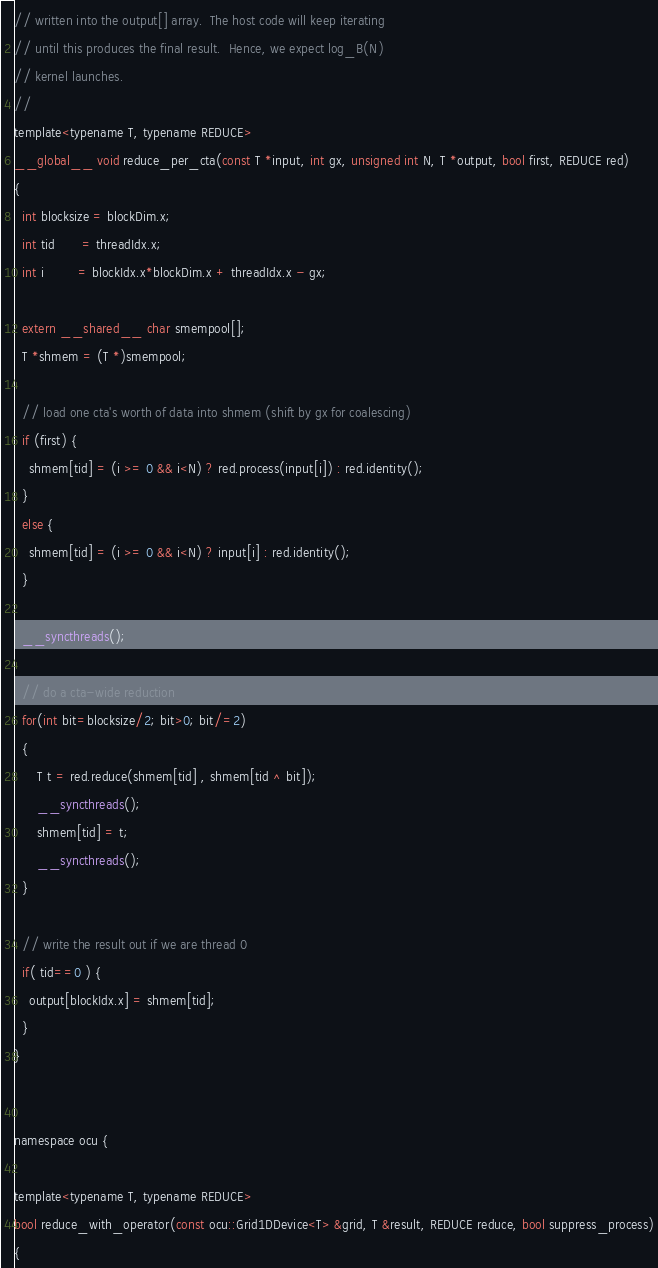Convert code to text. <code><loc_0><loc_0><loc_500><loc_500><_Cuda_>// written into the output[] array.  The host code will keep iterating
// until this produces the final result.  Hence, we expect log_B(N)
// kernel launches.
//
template<typename T, typename REDUCE>
__global__ void reduce_per_cta(const T *input, int gx, unsigned int N, T *output, bool first, REDUCE red)
{
  int blocksize = blockDim.x;
  int tid       = threadIdx.x;
  int i         = blockIdx.x*blockDim.x + threadIdx.x - gx;

  extern __shared__ char smempool[];
  T *shmem = (T *)smempool;

  // load one cta's worth of data into shmem (shift by gx for coalescing)
  if (first) {
    shmem[tid] = (i >= 0 && i<N) ? red.process(input[i]) : red.identity();
  }
  else {
    shmem[tid] = (i >= 0 && i<N) ? input[i] : red.identity();
  }

  __syncthreads();
    
  // do a cta-wide reduction
  for(int bit=blocksize/2; bit>0; bit/=2)
  {
      T t = red.reduce(shmem[tid] , shmem[tid ^ bit]);  
      __syncthreads();
      shmem[tid] = t;
      __syncthreads();
  }

  // write the result out if we are thread 0
  if( tid==0 ) {
    output[blockIdx.x] = shmem[tid];
  }
}


namespace ocu {

template<typename T, typename REDUCE>
bool reduce_with_operator(const ocu::Grid1DDevice<T> &grid, T &result, REDUCE reduce, bool suppress_process)
{</code> 